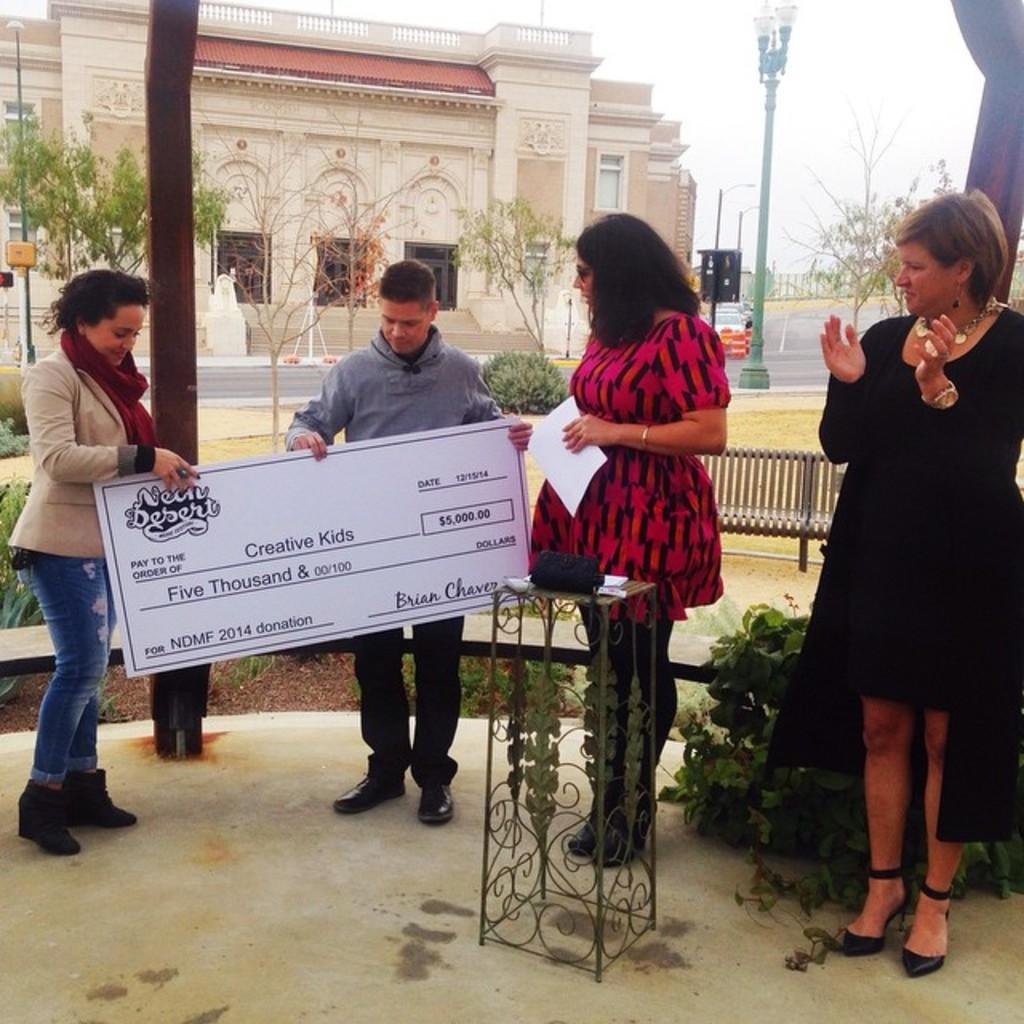How many people are in the image? There is a group of people in the image. What are two people doing in the image? Two people are holding a board. What can be seen behind the people? There are poles with lights and trees visible behind the people. What is in the background of the image? There is a building and the sky visible in the background. How many sheep are visible in the image? There are no sheep present in the image. What type of seed is being planted by the people in the image? There is no seed or planting activity depicted in the image. 